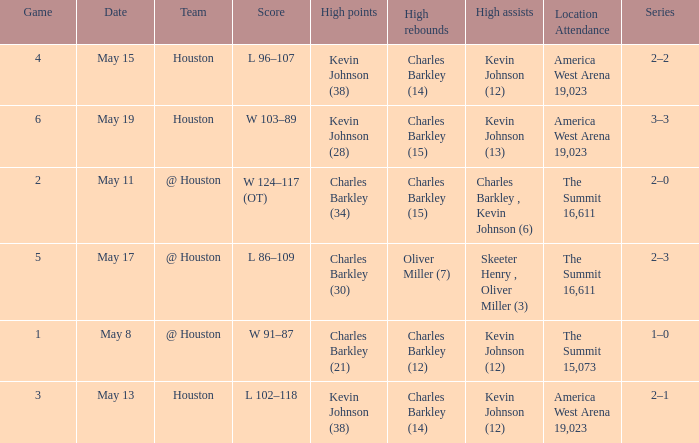Who did the high assists in the game where Charles Barkley (21) did the high points? Kevin Johnson (12). 